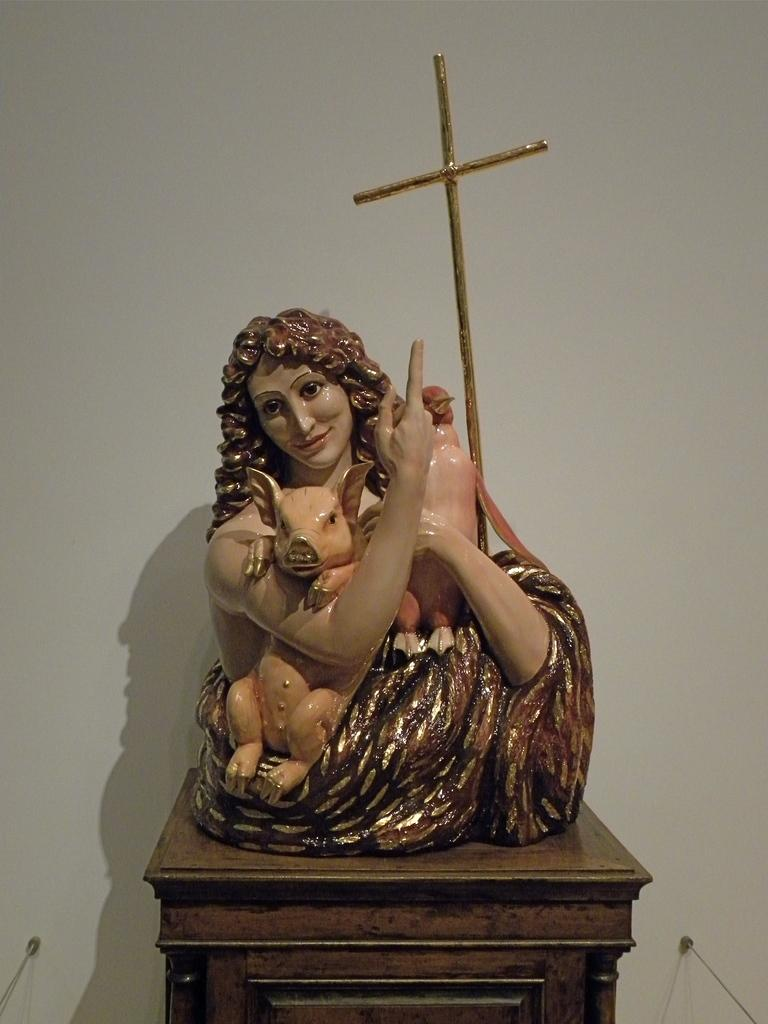What is the main subject in the foreground of the image? There is a sculpture on a table in the foreground of the image. What can be seen in the background of the image? There is a wall in the background of the image. Can you see any kisses on the sculpture in the image? There are no kisses visible on the sculpture in the image. Is there a trail of smoke coming from the sculpture in the image? There is no trail of smoke coming from the sculpture in the image. 